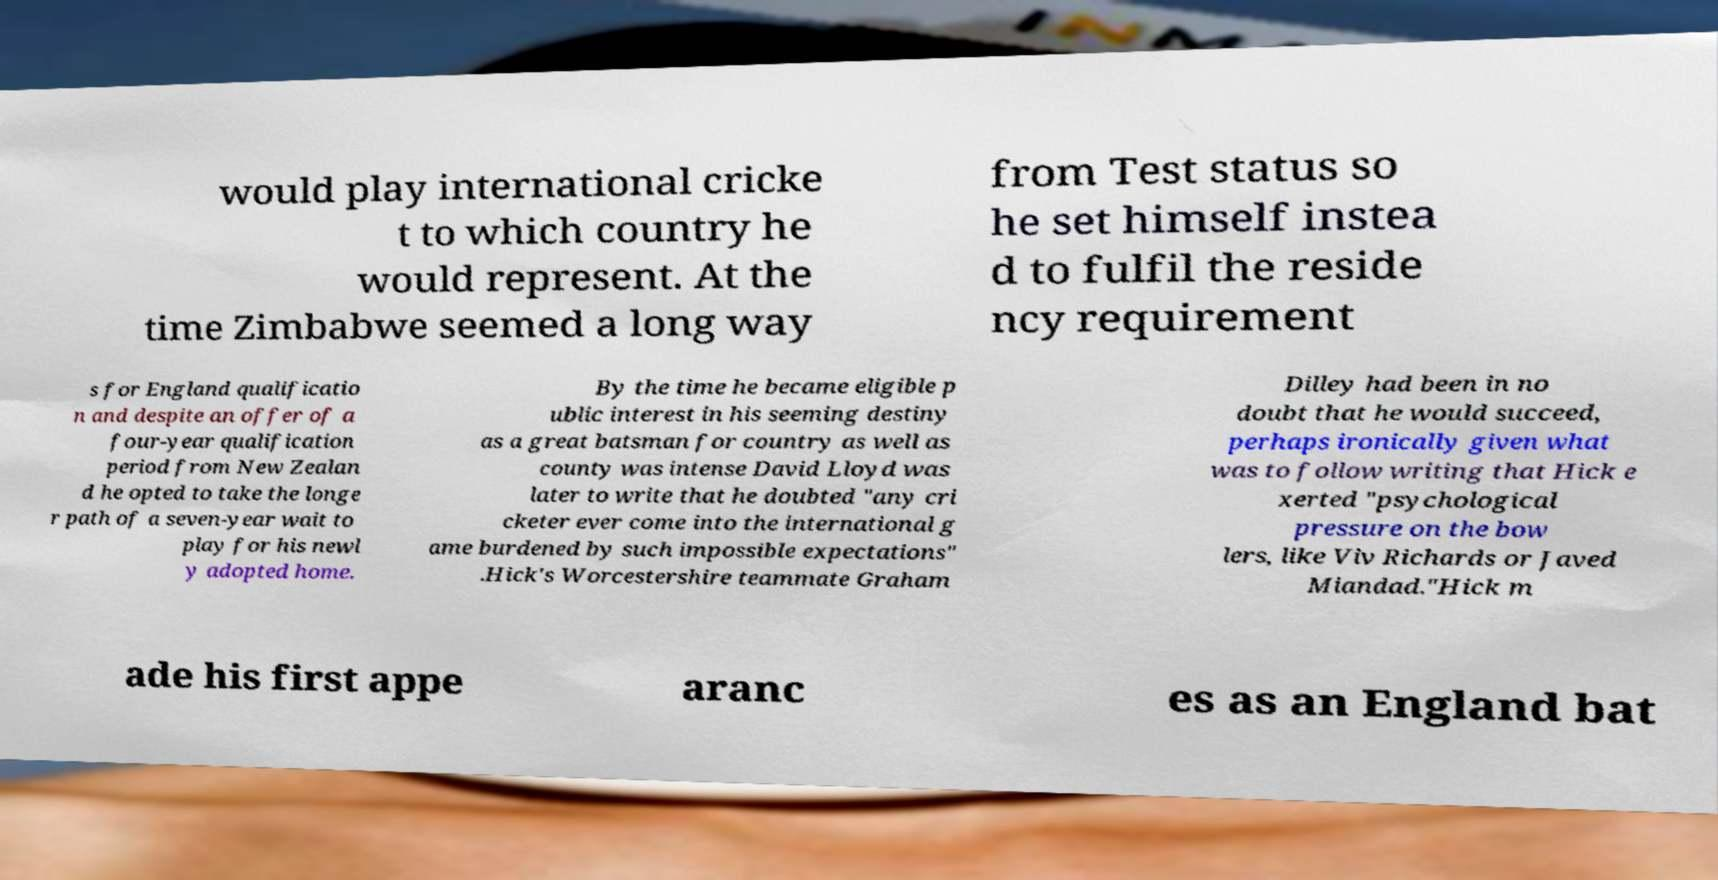Please read and relay the text visible in this image. What does it say? would play international cricke t to which country he would represent. At the time Zimbabwe seemed a long way from Test status so he set himself instea d to fulfil the reside ncy requirement s for England qualificatio n and despite an offer of a four-year qualification period from New Zealan d he opted to take the longe r path of a seven-year wait to play for his newl y adopted home. By the time he became eligible p ublic interest in his seeming destiny as a great batsman for country as well as county was intense David Lloyd was later to write that he doubted "any cri cketer ever come into the international g ame burdened by such impossible expectations" .Hick's Worcestershire teammate Graham Dilley had been in no doubt that he would succeed, perhaps ironically given what was to follow writing that Hick e xerted "psychological pressure on the bow lers, like Viv Richards or Javed Miandad."Hick m ade his first appe aranc es as an England bat 